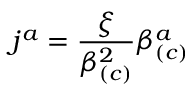<formula> <loc_0><loc_0><loc_500><loc_500>j ^ { a } = \frac { \xi } { \beta _ { \left ( c \right ) } ^ { 2 } } \beta _ { \left ( c \right ) } ^ { a }</formula> 